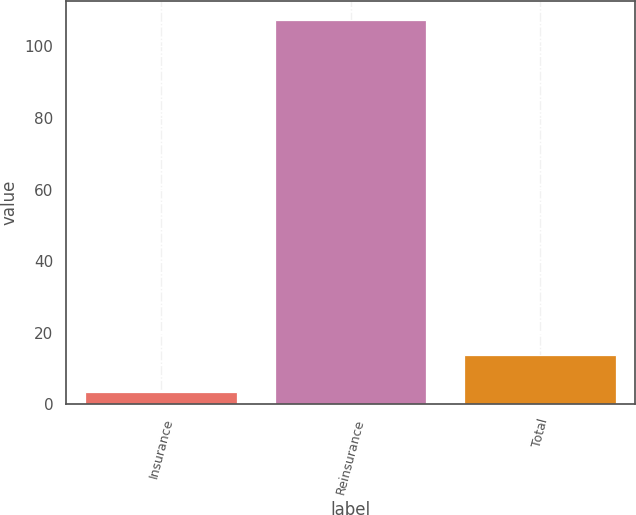Convert chart. <chart><loc_0><loc_0><loc_500><loc_500><bar_chart><fcel>Insurance<fcel>Reinsurance<fcel>Total<nl><fcel>3.5<fcel>107.3<fcel>13.9<nl></chart> 